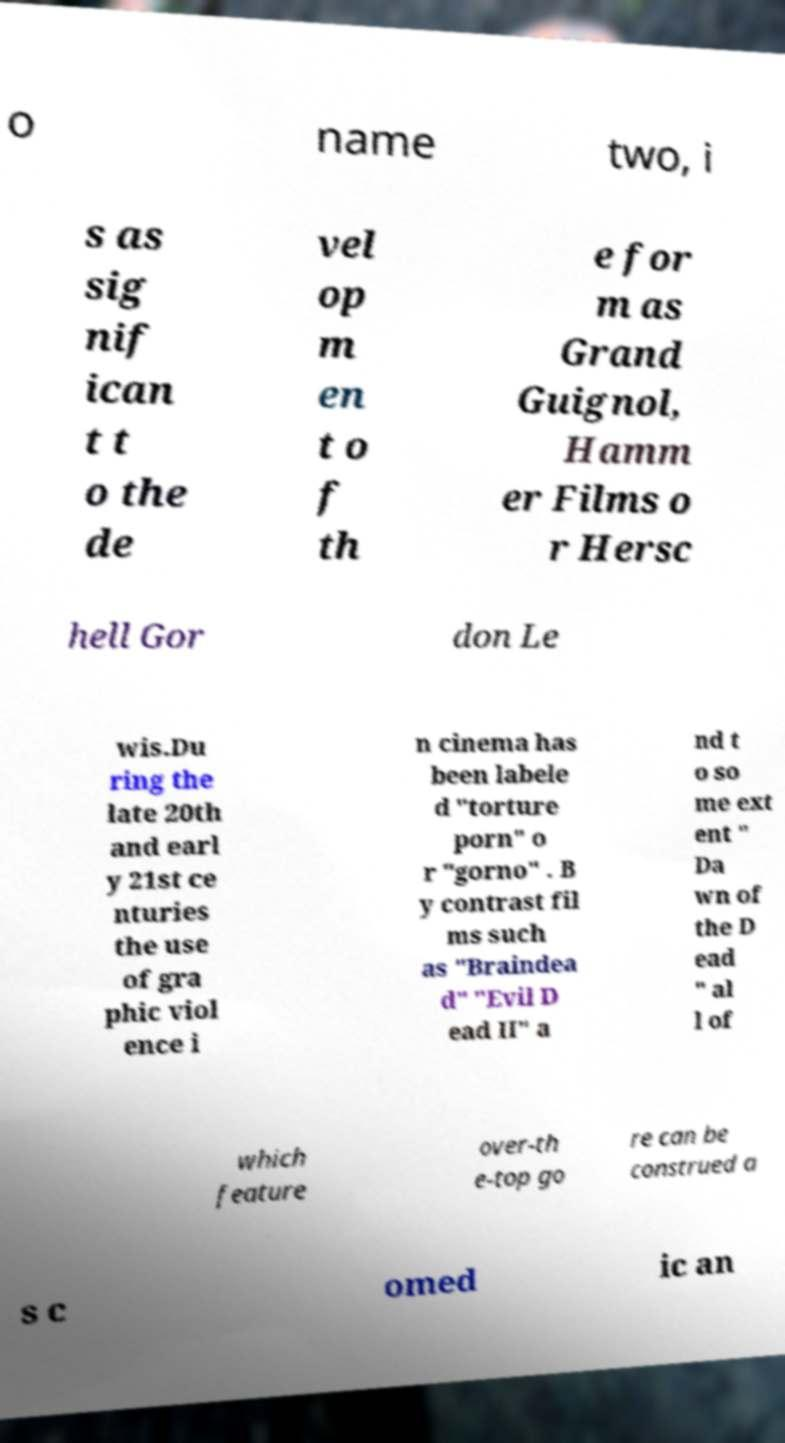There's text embedded in this image that I need extracted. Can you transcribe it verbatim? o name two, i s as sig nif ican t t o the de vel op m en t o f th e for m as Grand Guignol, Hamm er Films o r Hersc hell Gor don Le wis.Du ring the late 20th and earl y 21st ce nturies the use of gra phic viol ence i n cinema has been labele d "torture porn" o r "gorno" . B y contrast fil ms such as "Braindea d" "Evil D ead II" a nd t o so me ext ent " Da wn of the D ead " al l of which feature over-th e-top go re can be construed a s c omed ic an 